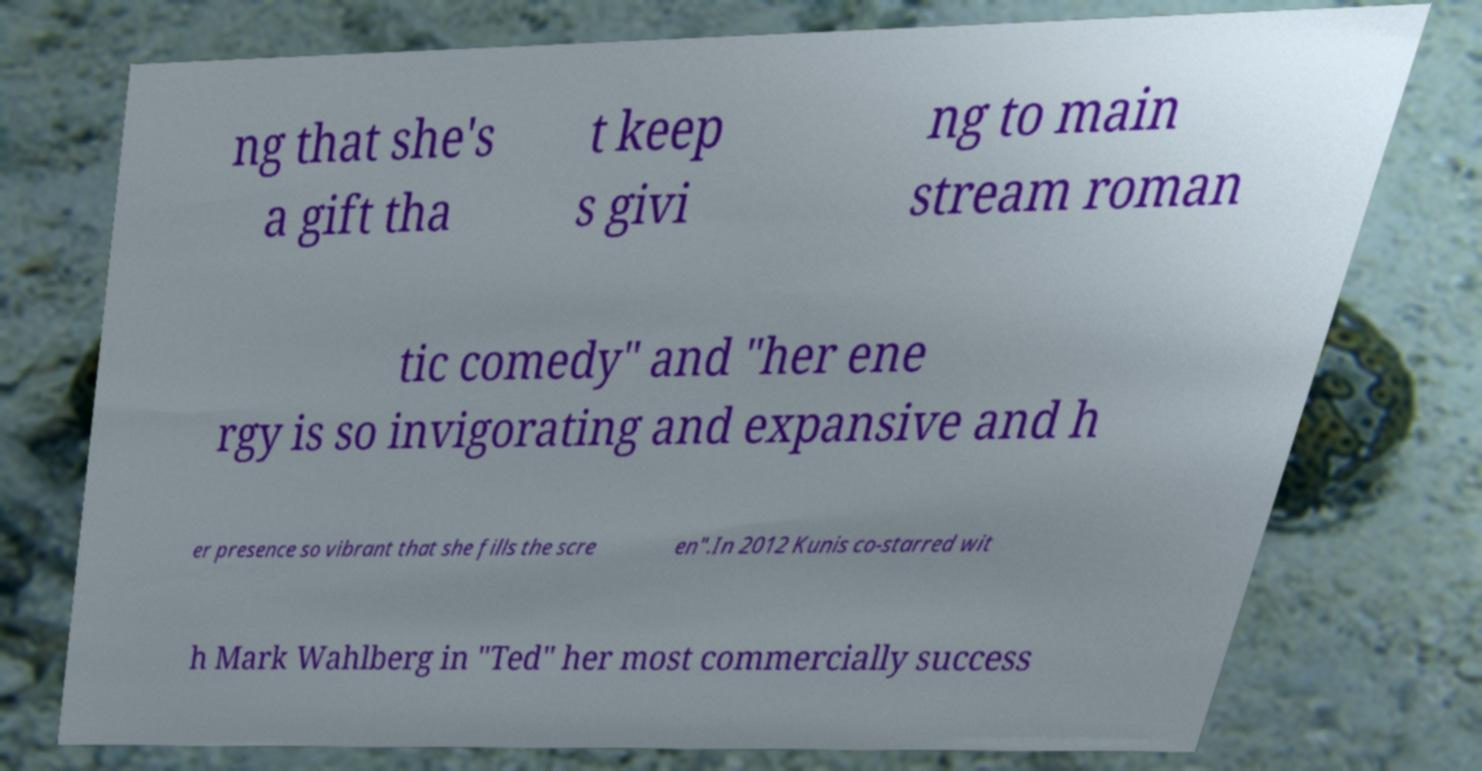There's text embedded in this image that I need extracted. Can you transcribe it verbatim? ng that she's a gift tha t keep s givi ng to main stream roman tic comedy" and "her ene rgy is so invigorating and expansive and h er presence so vibrant that she fills the scre en".In 2012 Kunis co-starred wit h Mark Wahlberg in "Ted" her most commercially success 